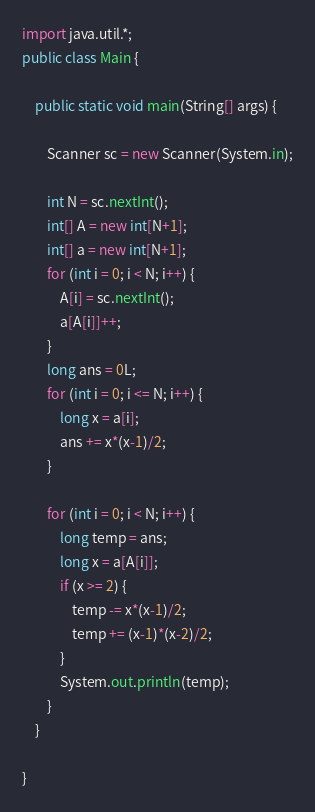Convert code to text. <code><loc_0><loc_0><loc_500><loc_500><_Java_>import java.util.*;
public class Main {

	public static void main(String[] args) {

		Scanner sc = new Scanner(System.in);
		
		int N = sc.nextInt();
		int[] A = new int[N+1];
		int[] a = new int[N+1];
		for (int i = 0; i < N; i++) {
			A[i] = sc.nextInt();
			a[A[i]]++;
		}
		long ans = 0L;
		for (int i = 0; i <= N; i++) {
			long x = a[i];
			ans += x*(x-1)/2;
		}

		for (int i = 0; i < N; i++) {
			long temp = ans;
			long x = a[A[i]];
			if (x >= 2) {
				temp -= x*(x-1)/2;
				temp += (x-1)*(x-2)/2;
			}
			System.out.println(temp);
		}
	}

}</code> 